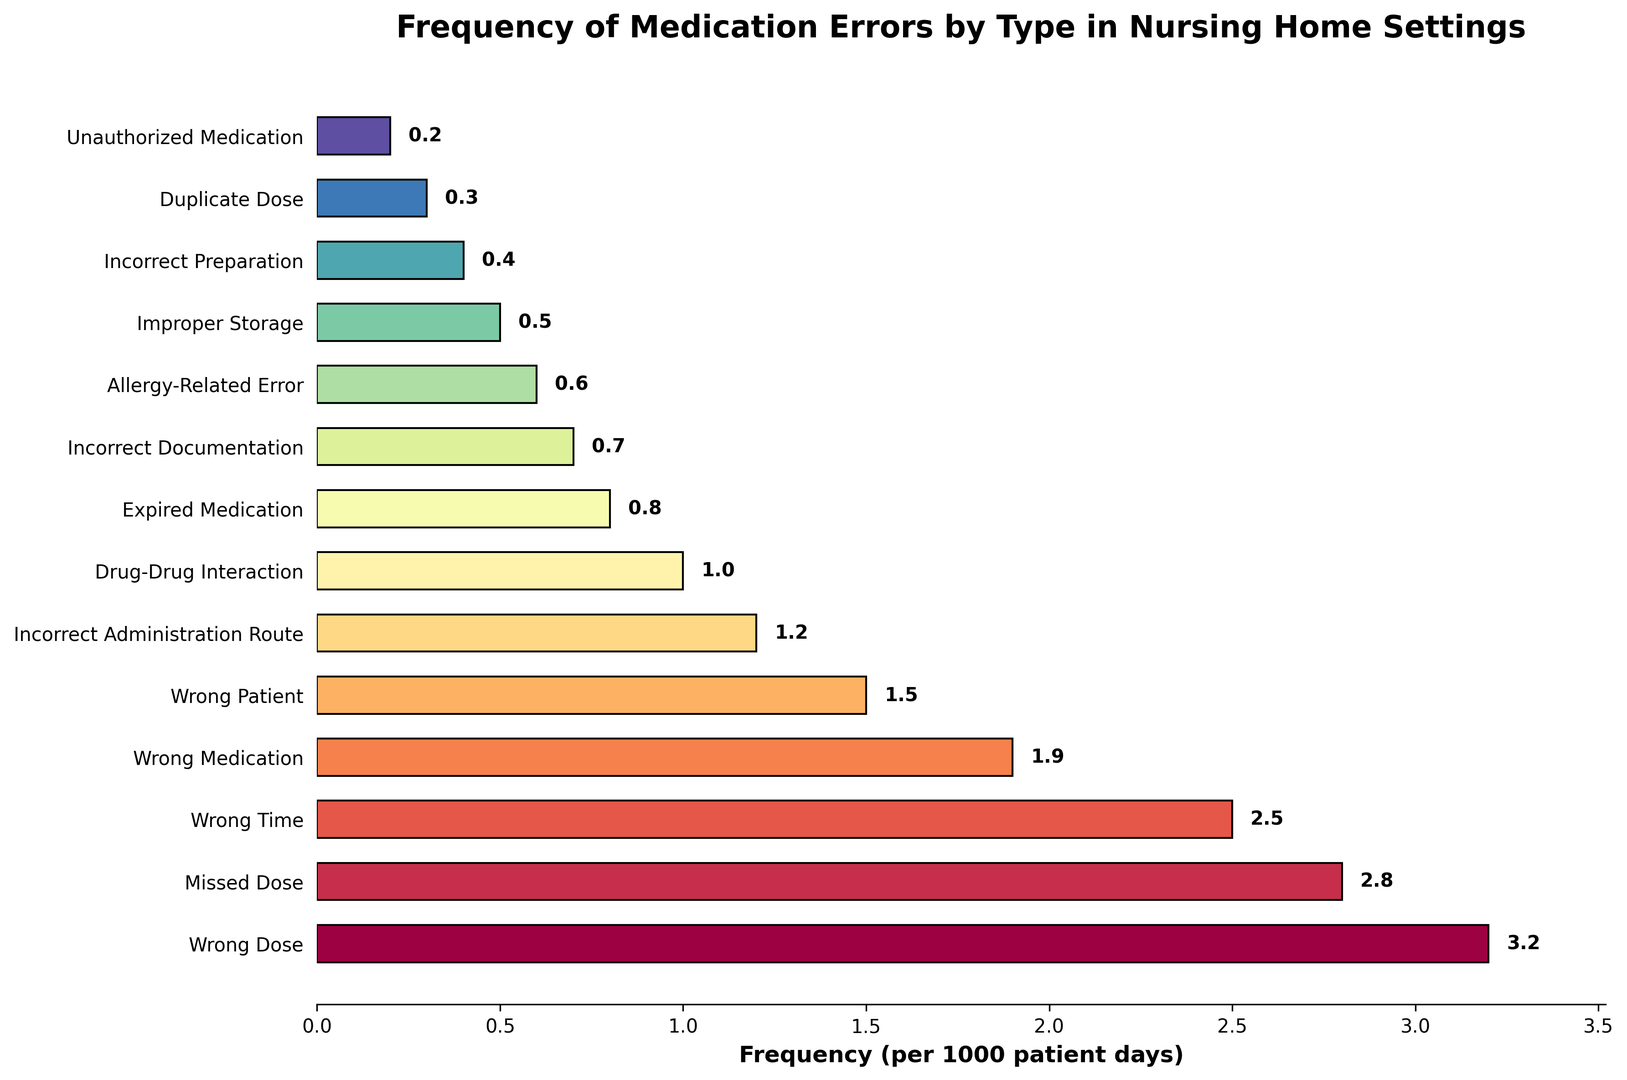What type of medication error has the highest frequency? To find the highest frequency, look at the lengths of the bars and compare them. The longest bar corresponds to the type "Wrong Dose" with a frequency of 3.2 per 1000 patient days.
Answer: Wrong Dose Which is more frequent, missed dose or wrong medication? Compare the lengths of the bars for "Missed Dose" and "Wrong Medication". "Missed Dose" has a frequency of 2.8, while "Wrong Medication" has a frequency of 1.9.
Answer: Missed Dose What is the combined frequency of incorrect administration route and drug-drug interaction errors? Add the frequencies of "Incorrect Administration Route" (1.2) and "Drug-Drug Interaction" (1.0). The sum is 1.2 + 1.0 = 2.2.
Answer: 2.2 How many medication error types have a frequency less than 1.0? Count the bars representing frequencies less than 1.0. These types are "Expired Medication" (0.8), "Incorrect Documentation" (0.7), "Allergy-Related Error" (0.6), "Improper Storage" (0.5), "Incorrect Preparation" (0.4), "Duplicate Dose" (0.3), "Unauthorized Medication" (0.2). There are 7 such types.
Answer: 7 Which type of error has the lowest frequency? Identify the shortest bar, which corresponds to "Unauthorized Medication" with a frequency of 0.2.
Answer: Unauthorized Medication Is the frequency of wrong patient errors greater than incorrect documentation errors? Compare the bars for "Wrong Patient" (1.5) and "Incorrect Documentation" (0.7). "Wrong Patient" has a greater frequency.
Answer: Yes What is the difference in frequency between wrong time and expired medication errors? Subtract the frequency of "Expired Medication" (0.8) from the frequency of "Wrong Time" (2.5): 2.5 - 0.8 = 1.7.
Answer: 1.7 What is the average frequency of the top three types of medication errors? The top three types are "Wrong Dose" (3.2), "Missed Dose" (2.8), and "Wrong Time" (2.5). Their sum is 3.2 + 2.8 + 2.5 = 8.5. The average is 8.5 / 3 = 2.83.
Answer: 2.83 What types of medication errors have a frequency exactly or above 1.0 but below 2.0? These types are "Wrong Medication" (1.9), "Wrong Patient" (1.5), "Incorrect Administration Route" (1.2), and "Drug-Drug Interaction" (1.0).
Answer: Wrong Medication, Wrong Patient, Incorrect Administration Route, Drug-Drug Interaction 